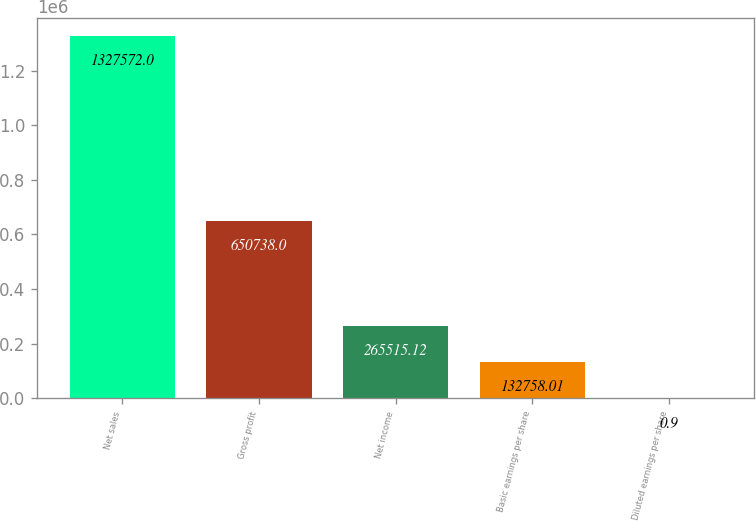Convert chart. <chart><loc_0><loc_0><loc_500><loc_500><bar_chart><fcel>Net sales<fcel>Gross profit<fcel>Net income<fcel>Basic earnings per share<fcel>Diluted earnings per share<nl><fcel>1.32757e+06<fcel>650738<fcel>265515<fcel>132758<fcel>0.9<nl></chart> 